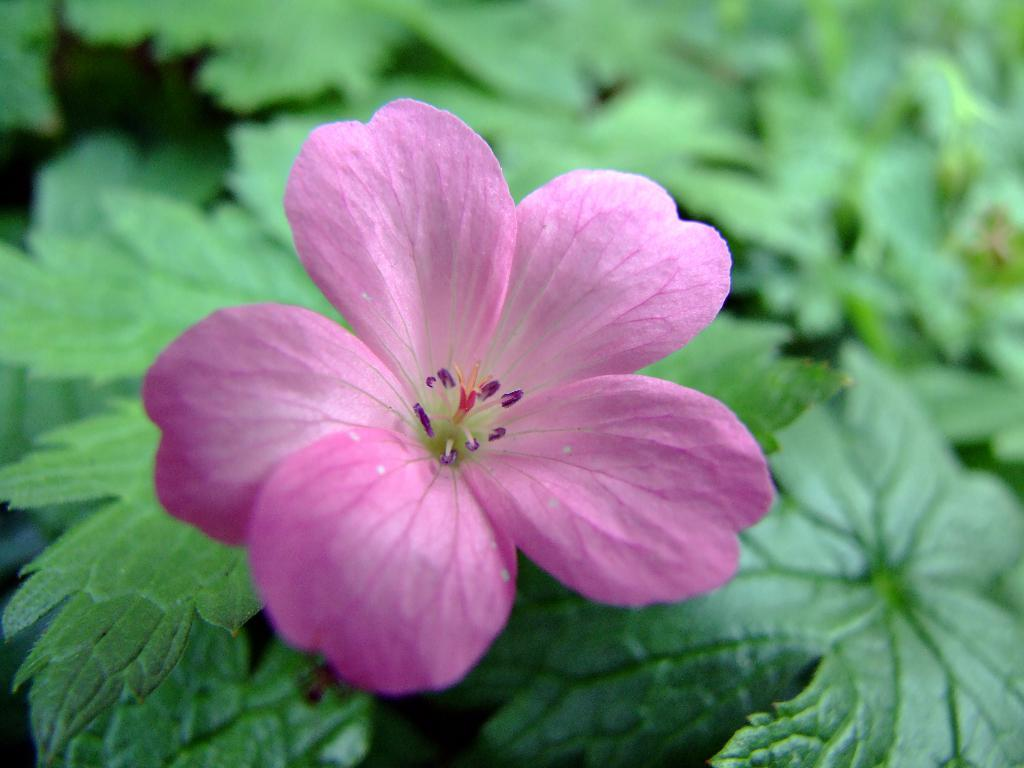What is the main subject in the foreground of the image? There is a flower in the foreground of the image. What can be seen in the background of the image? There are plants in the background of the image. How many legs can be seen on the flower in the image? Flowers do not have legs, so there are no legs visible on the flower in the image. 